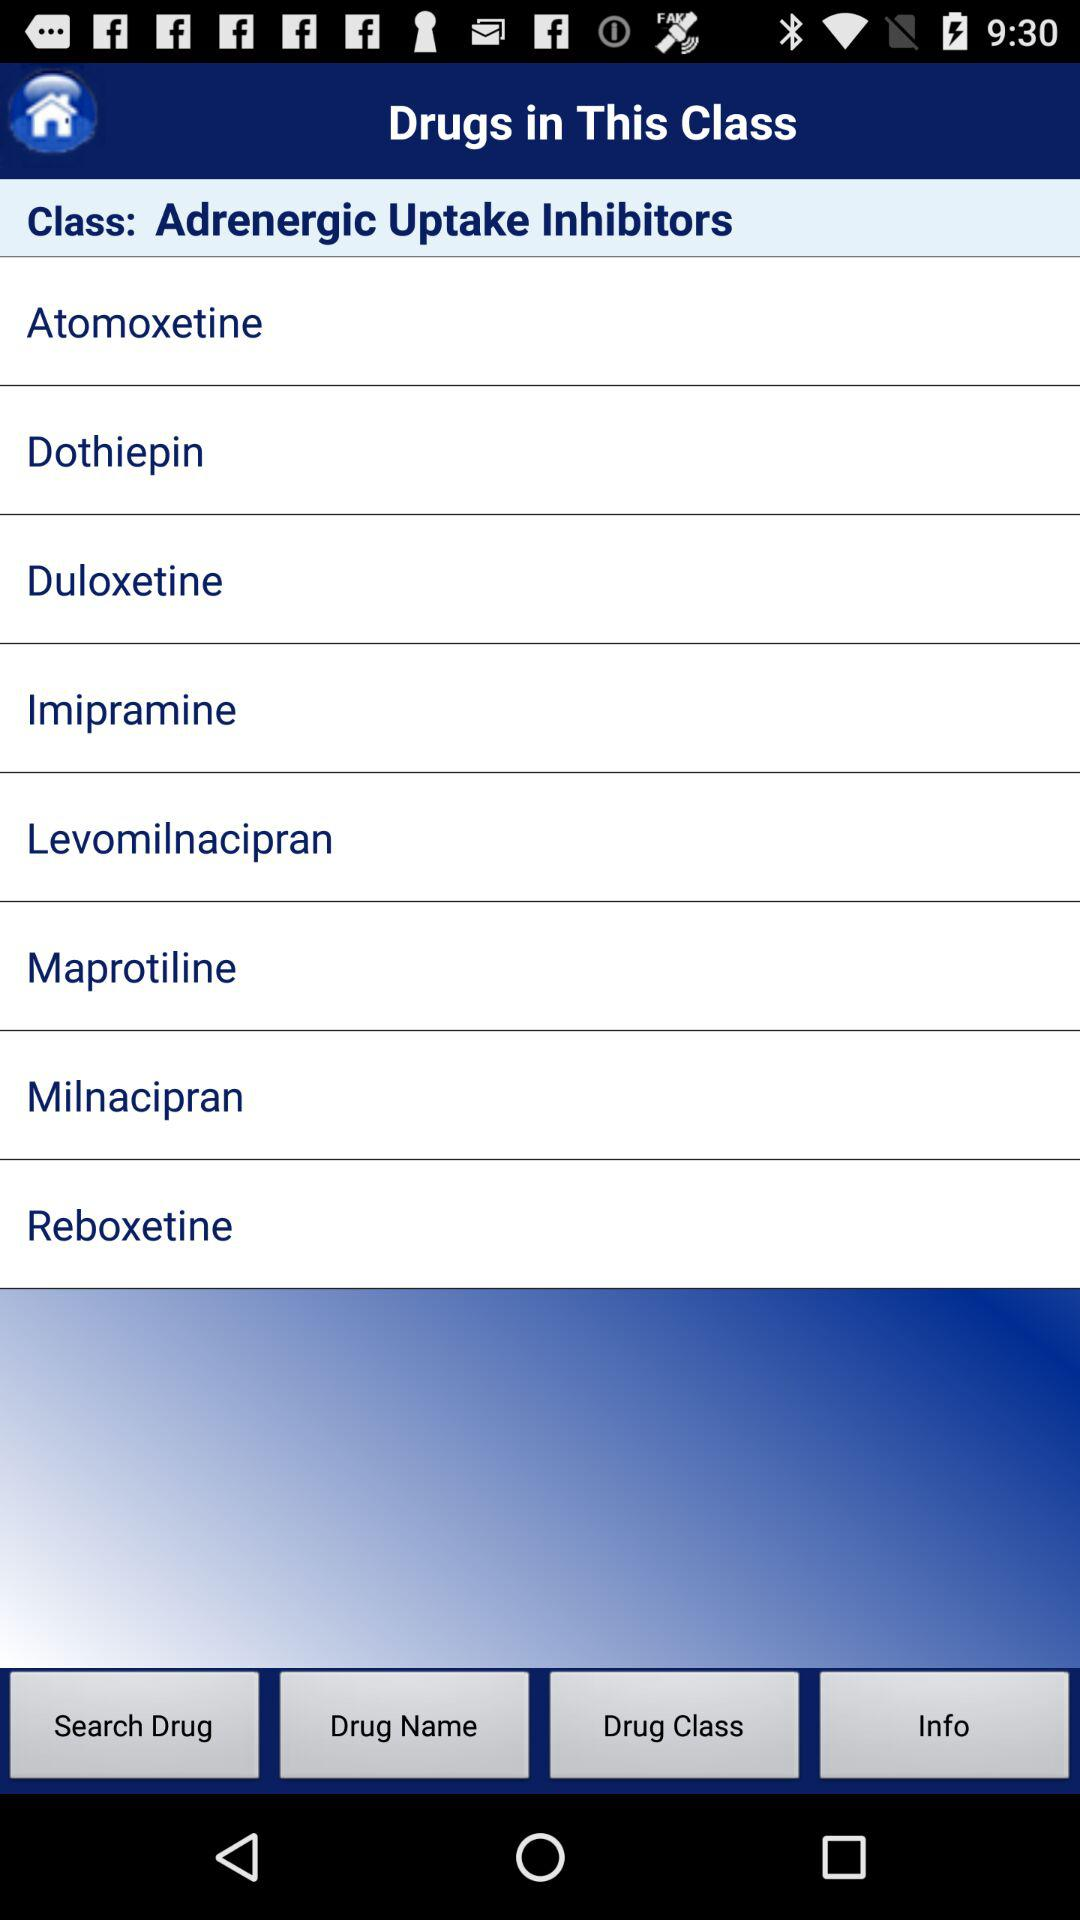What are the names of the different drugs listed in the class? The names of the different drugs listed in the class are "Atomoxetine", "Dothiepin", "Duloxetine", "Imipramine", "Levomilnacipran", "Maprotiline", "Milnacipran" and "Reboxetine". 